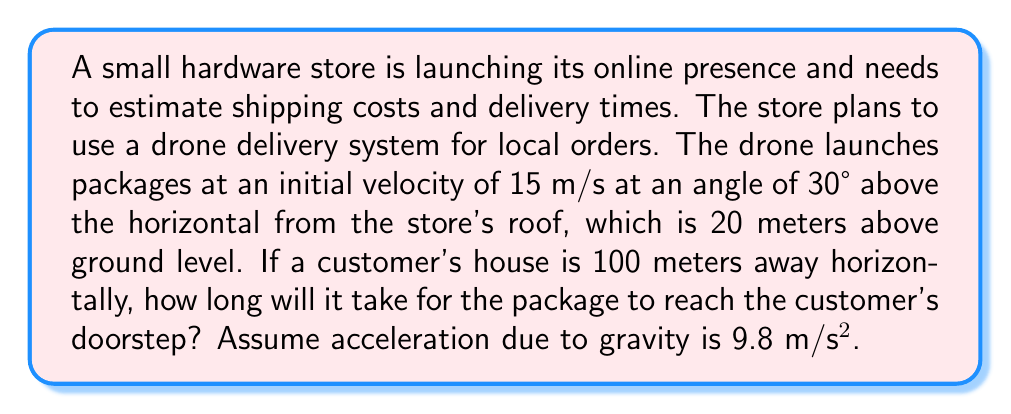Provide a solution to this math problem. To solve this problem, we'll use the equations of projectile motion. Let's break it down step by step:

1) First, let's identify the known variables:
   - Initial velocity, $v_0 = 15$ m/s
   - Launch angle, $\theta = 30°$
   - Initial height, $h_0 = 20$ m
   - Horizontal distance, $x = 100$ m
   - Acceleration due to gravity, $g = 9.8$ m/s²

2) We need to find the time it takes for the package to travel 100 meters horizontally. We can use the horizontal component of motion for this:

   $$x = v_0 \cos(\theta) \cdot t$$

3) Rearranging this equation to solve for t:

   $$t = \frac{x}{v_0 \cos(\theta)}$$

4) Now, let's substitute the values:

   $$t = \frac{100}{15 \cos(30°)}$$

5) Evaluate $\cos(30°) \approx 0.866$:

   $$t = \frac{100}{15 \cdot 0.866} \approx 7.707 \text{ seconds}$$

6) To verify if this is the correct time, we need to check if the package has reached the ground at this time. We can use the vertical motion equation:

   $$y = h_0 + v_0 \sin(\theta) \cdot t - \frac{1}{2}gt^2$$

7) Substituting the values:

   $$y = 20 + 15 \sin(30°) \cdot 7.707 - \frac{1}{2} \cdot 9.8 \cdot 7.707^2$$

8) Evaluating this equation:

   $$y = 20 + 57.80 - 290.54 = -212.74 \text{ meters}$$

9) Since y is negative, this confirms that the package has reached the ground before 7.707 seconds.

10) To find the exact time when the package hits the ground, we need to solve the quadratic equation:

    $$0 = 20 + 15 \sin(30°) \cdot t - \frac{1}{2} \cdot 9.8 \cdot t^2$$

11) Using the quadratic formula, we get two solutions: t ≈ 1.59 seconds and t ≈ 7.35 seconds.

12) The smaller time (1.59 seconds) is when the package would hit the ground if launched horizontally. The larger time (7.35 seconds) is when it hits the ground at 100 meters away.
Answer: The package will reach the customer's doorstep in approximately 7.35 seconds. 